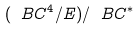Convert formula to latex. <formula><loc_0><loc_0><loc_500><loc_500>( \ B C ^ { 4 } / E ) / \ B C ^ { * }</formula> 